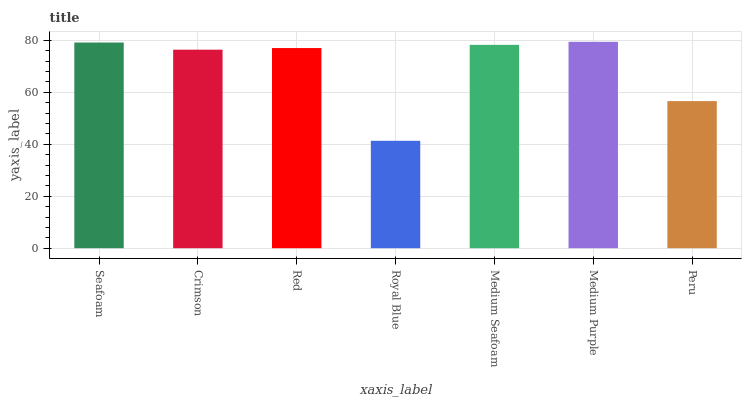Is Royal Blue the minimum?
Answer yes or no. Yes. Is Medium Purple the maximum?
Answer yes or no. Yes. Is Crimson the minimum?
Answer yes or no. No. Is Crimson the maximum?
Answer yes or no. No. Is Seafoam greater than Crimson?
Answer yes or no. Yes. Is Crimson less than Seafoam?
Answer yes or no. Yes. Is Crimson greater than Seafoam?
Answer yes or no. No. Is Seafoam less than Crimson?
Answer yes or no. No. Is Red the high median?
Answer yes or no. Yes. Is Red the low median?
Answer yes or no. Yes. Is Peru the high median?
Answer yes or no. No. Is Peru the low median?
Answer yes or no. No. 